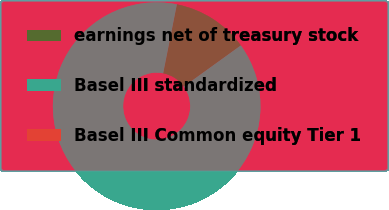<chart> <loc_0><loc_0><loc_500><loc_500><pie_chart><fcel>earnings net of treasury stock<fcel>Basel III standardized<fcel>Basel III Common equity Tier 1<nl><fcel>11.93%<fcel>88.07%<fcel>0.0%<nl></chart> 